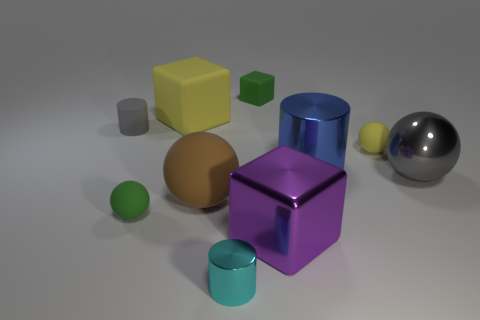Subtract 1 spheres. How many spheres are left? 3 Subtract all shiny cylinders. How many cylinders are left? 1 Subtract all yellow spheres. How many spheres are left? 3 Subtract all blue spheres. Subtract all blue cylinders. How many spheres are left? 4 Subtract all blocks. How many objects are left? 7 Subtract 1 blue cylinders. How many objects are left? 9 Subtract all tiny gray rubber cylinders. Subtract all purple metal objects. How many objects are left? 8 Add 9 blue shiny cylinders. How many blue shiny cylinders are left? 10 Add 4 small gray shiny cubes. How many small gray shiny cubes exist? 4 